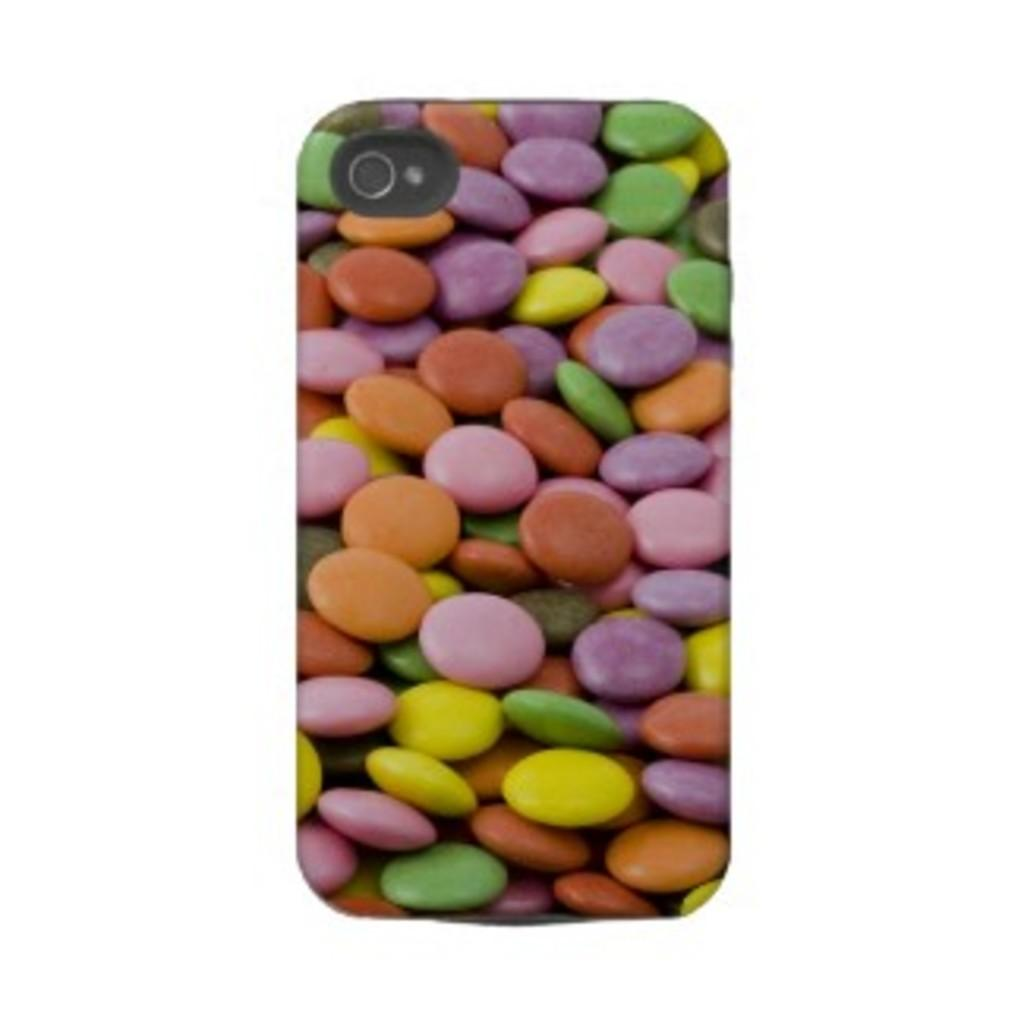What part of a mobile is visible in the image? The back cover of a mobile is visible in the image. What type of nail is used to burst the mobile in the image? There is no nail or bursting action present in the image; it only shows the back cover of a mobile. 